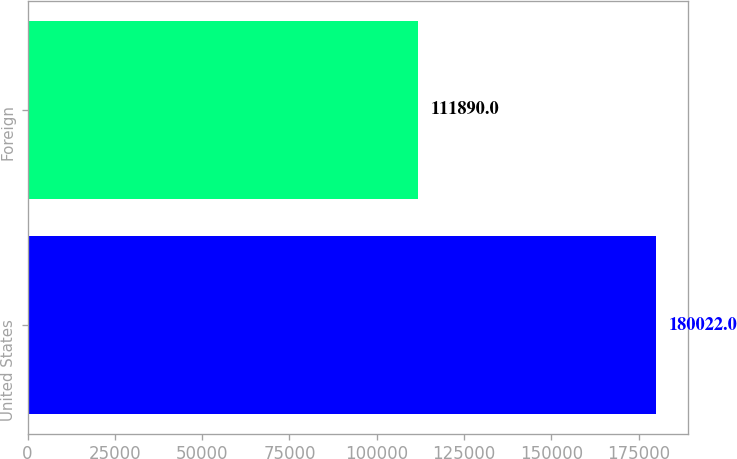Convert chart to OTSL. <chart><loc_0><loc_0><loc_500><loc_500><bar_chart><fcel>United States<fcel>Foreign<nl><fcel>180022<fcel>111890<nl></chart> 